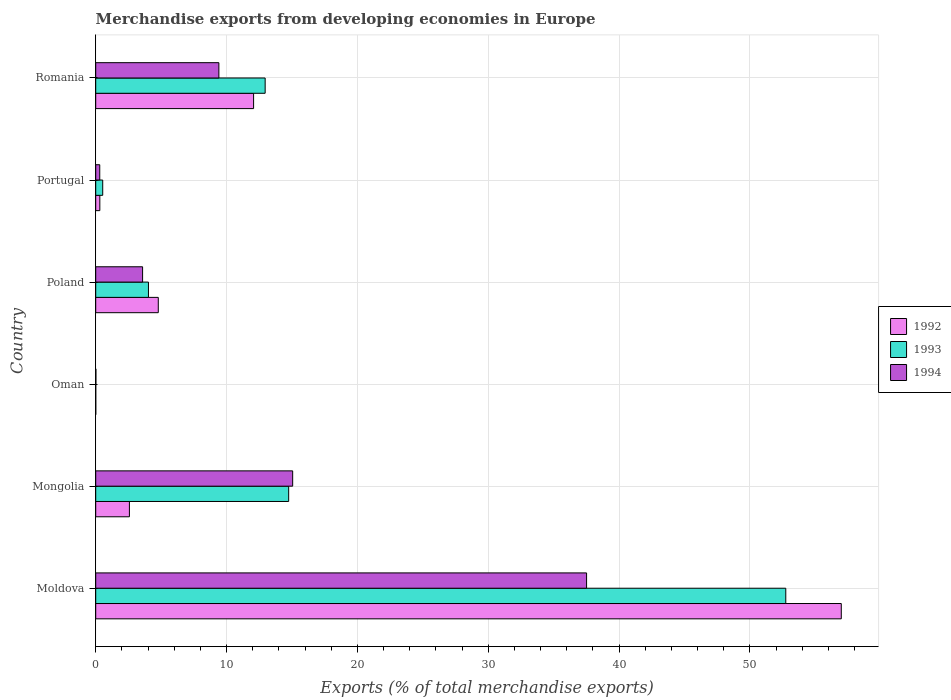Are the number of bars per tick equal to the number of legend labels?
Give a very brief answer. Yes. How many bars are there on the 2nd tick from the top?
Your answer should be compact. 3. What is the label of the 6th group of bars from the top?
Ensure brevity in your answer.  Moldova. What is the percentage of total merchandise exports in 1993 in Portugal?
Your answer should be compact. 0.54. Across all countries, what is the maximum percentage of total merchandise exports in 1993?
Your response must be concise. 52.74. Across all countries, what is the minimum percentage of total merchandise exports in 1993?
Keep it short and to the point. 0. In which country was the percentage of total merchandise exports in 1992 maximum?
Provide a short and direct response. Moldova. In which country was the percentage of total merchandise exports in 1993 minimum?
Offer a very short reply. Oman. What is the total percentage of total merchandise exports in 1993 in the graph?
Give a very brief answer. 85. What is the difference between the percentage of total merchandise exports in 1992 in Moldova and that in Poland?
Keep it short and to the point. 52.2. What is the difference between the percentage of total merchandise exports in 1992 in Moldova and the percentage of total merchandise exports in 1994 in Romania?
Your response must be concise. 47.57. What is the average percentage of total merchandise exports in 1993 per country?
Offer a very short reply. 14.17. What is the difference between the percentage of total merchandise exports in 1992 and percentage of total merchandise exports in 1993 in Mongolia?
Your response must be concise. -12.17. What is the ratio of the percentage of total merchandise exports in 1993 in Oman to that in Poland?
Provide a short and direct response. 0. Is the percentage of total merchandise exports in 1993 in Moldova less than that in Oman?
Provide a succinct answer. No. What is the difference between the highest and the second highest percentage of total merchandise exports in 1992?
Give a very brief answer. 44.91. What is the difference between the highest and the lowest percentage of total merchandise exports in 1993?
Offer a terse response. 52.74. What does the 2nd bar from the bottom in Portugal represents?
Provide a short and direct response. 1993. Is it the case that in every country, the sum of the percentage of total merchandise exports in 1994 and percentage of total merchandise exports in 1992 is greater than the percentage of total merchandise exports in 1993?
Ensure brevity in your answer.  Yes. How many countries are there in the graph?
Keep it short and to the point. 6. What is the difference between two consecutive major ticks on the X-axis?
Keep it short and to the point. 10. Are the values on the major ticks of X-axis written in scientific E-notation?
Ensure brevity in your answer.  No. Where does the legend appear in the graph?
Provide a succinct answer. Center right. How many legend labels are there?
Keep it short and to the point. 3. What is the title of the graph?
Give a very brief answer. Merchandise exports from developing economies in Europe. What is the label or title of the X-axis?
Make the answer very short. Exports (% of total merchandise exports). What is the label or title of the Y-axis?
Offer a very short reply. Country. What is the Exports (% of total merchandise exports) of 1992 in Moldova?
Your answer should be compact. 56.98. What is the Exports (% of total merchandise exports) in 1993 in Moldova?
Keep it short and to the point. 52.74. What is the Exports (% of total merchandise exports) in 1994 in Moldova?
Your answer should be compact. 37.51. What is the Exports (% of total merchandise exports) in 1992 in Mongolia?
Your answer should be very brief. 2.57. What is the Exports (% of total merchandise exports) in 1993 in Mongolia?
Ensure brevity in your answer.  14.75. What is the Exports (% of total merchandise exports) of 1994 in Mongolia?
Keep it short and to the point. 15.05. What is the Exports (% of total merchandise exports) of 1992 in Oman?
Provide a short and direct response. 0. What is the Exports (% of total merchandise exports) of 1993 in Oman?
Give a very brief answer. 0. What is the Exports (% of total merchandise exports) of 1994 in Oman?
Offer a terse response. 0.01. What is the Exports (% of total merchandise exports) in 1992 in Poland?
Keep it short and to the point. 4.78. What is the Exports (% of total merchandise exports) in 1993 in Poland?
Give a very brief answer. 4.03. What is the Exports (% of total merchandise exports) of 1994 in Poland?
Offer a very short reply. 3.58. What is the Exports (% of total merchandise exports) in 1992 in Portugal?
Offer a terse response. 0.32. What is the Exports (% of total merchandise exports) of 1993 in Portugal?
Your response must be concise. 0.54. What is the Exports (% of total merchandise exports) in 1994 in Portugal?
Give a very brief answer. 0.31. What is the Exports (% of total merchandise exports) in 1992 in Romania?
Offer a terse response. 12.07. What is the Exports (% of total merchandise exports) in 1993 in Romania?
Your answer should be very brief. 12.95. What is the Exports (% of total merchandise exports) of 1994 in Romania?
Your response must be concise. 9.41. Across all countries, what is the maximum Exports (% of total merchandise exports) in 1992?
Your response must be concise. 56.98. Across all countries, what is the maximum Exports (% of total merchandise exports) of 1993?
Your response must be concise. 52.74. Across all countries, what is the maximum Exports (% of total merchandise exports) of 1994?
Offer a terse response. 37.51. Across all countries, what is the minimum Exports (% of total merchandise exports) of 1992?
Offer a very short reply. 0. Across all countries, what is the minimum Exports (% of total merchandise exports) of 1993?
Offer a terse response. 0. Across all countries, what is the minimum Exports (% of total merchandise exports) in 1994?
Give a very brief answer. 0.01. What is the total Exports (% of total merchandise exports) of 1992 in the graph?
Offer a terse response. 76.72. What is the total Exports (% of total merchandise exports) of 1993 in the graph?
Provide a short and direct response. 85. What is the total Exports (% of total merchandise exports) in 1994 in the graph?
Offer a very short reply. 65.88. What is the difference between the Exports (% of total merchandise exports) of 1992 in Moldova and that in Mongolia?
Offer a very short reply. 54.4. What is the difference between the Exports (% of total merchandise exports) of 1993 in Moldova and that in Mongolia?
Offer a terse response. 37.99. What is the difference between the Exports (% of total merchandise exports) of 1994 in Moldova and that in Mongolia?
Your response must be concise. 22.46. What is the difference between the Exports (% of total merchandise exports) in 1992 in Moldova and that in Oman?
Your answer should be compact. 56.97. What is the difference between the Exports (% of total merchandise exports) in 1993 in Moldova and that in Oman?
Provide a succinct answer. 52.74. What is the difference between the Exports (% of total merchandise exports) in 1994 in Moldova and that in Oman?
Offer a very short reply. 37.5. What is the difference between the Exports (% of total merchandise exports) of 1992 in Moldova and that in Poland?
Keep it short and to the point. 52.2. What is the difference between the Exports (% of total merchandise exports) of 1993 in Moldova and that in Poland?
Your answer should be compact. 48.71. What is the difference between the Exports (% of total merchandise exports) in 1994 in Moldova and that in Poland?
Make the answer very short. 33.93. What is the difference between the Exports (% of total merchandise exports) in 1992 in Moldova and that in Portugal?
Provide a short and direct response. 56.66. What is the difference between the Exports (% of total merchandise exports) of 1993 in Moldova and that in Portugal?
Provide a succinct answer. 52.2. What is the difference between the Exports (% of total merchandise exports) in 1994 in Moldova and that in Portugal?
Offer a very short reply. 37.2. What is the difference between the Exports (% of total merchandise exports) in 1992 in Moldova and that in Romania?
Make the answer very short. 44.91. What is the difference between the Exports (% of total merchandise exports) of 1993 in Moldova and that in Romania?
Offer a terse response. 39.79. What is the difference between the Exports (% of total merchandise exports) in 1994 in Moldova and that in Romania?
Keep it short and to the point. 28.1. What is the difference between the Exports (% of total merchandise exports) of 1992 in Mongolia and that in Oman?
Provide a succinct answer. 2.57. What is the difference between the Exports (% of total merchandise exports) in 1993 in Mongolia and that in Oman?
Provide a short and direct response. 14.75. What is the difference between the Exports (% of total merchandise exports) of 1994 in Mongolia and that in Oman?
Provide a short and direct response. 15.04. What is the difference between the Exports (% of total merchandise exports) of 1992 in Mongolia and that in Poland?
Give a very brief answer. -2.21. What is the difference between the Exports (% of total merchandise exports) in 1993 in Mongolia and that in Poland?
Your response must be concise. 10.72. What is the difference between the Exports (% of total merchandise exports) in 1994 in Mongolia and that in Poland?
Your answer should be very brief. 11.47. What is the difference between the Exports (% of total merchandise exports) of 1992 in Mongolia and that in Portugal?
Ensure brevity in your answer.  2.26. What is the difference between the Exports (% of total merchandise exports) in 1993 in Mongolia and that in Portugal?
Your answer should be very brief. 14.21. What is the difference between the Exports (% of total merchandise exports) in 1994 in Mongolia and that in Portugal?
Ensure brevity in your answer.  14.74. What is the difference between the Exports (% of total merchandise exports) in 1992 in Mongolia and that in Romania?
Your response must be concise. -9.49. What is the difference between the Exports (% of total merchandise exports) in 1993 in Mongolia and that in Romania?
Ensure brevity in your answer.  1.8. What is the difference between the Exports (% of total merchandise exports) of 1994 in Mongolia and that in Romania?
Make the answer very short. 5.64. What is the difference between the Exports (% of total merchandise exports) of 1992 in Oman and that in Poland?
Keep it short and to the point. -4.78. What is the difference between the Exports (% of total merchandise exports) of 1993 in Oman and that in Poland?
Provide a succinct answer. -4.03. What is the difference between the Exports (% of total merchandise exports) in 1994 in Oman and that in Poland?
Give a very brief answer. -3.57. What is the difference between the Exports (% of total merchandise exports) in 1992 in Oman and that in Portugal?
Your response must be concise. -0.31. What is the difference between the Exports (% of total merchandise exports) of 1993 in Oman and that in Portugal?
Your response must be concise. -0.53. What is the difference between the Exports (% of total merchandise exports) in 1994 in Oman and that in Portugal?
Offer a terse response. -0.29. What is the difference between the Exports (% of total merchandise exports) in 1992 in Oman and that in Romania?
Your answer should be compact. -12.06. What is the difference between the Exports (% of total merchandise exports) in 1993 in Oman and that in Romania?
Your answer should be very brief. -12.95. What is the difference between the Exports (% of total merchandise exports) in 1994 in Oman and that in Romania?
Provide a succinct answer. -9.4. What is the difference between the Exports (% of total merchandise exports) in 1992 in Poland and that in Portugal?
Keep it short and to the point. 4.47. What is the difference between the Exports (% of total merchandise exports) of 1993 in Poland and that in Portugal?
Give a very brief answer. 3.49. What is the difference between the Exports (% of total merchandise exports) of 1994 in Poland and that in Portugal?
Your answer should be compact. 3.27. What is the difference between the Exports (% of total merchandise exports) in 1992 in Poland and that in Romania?
Your answer should be compact. -7.28. What is the difference between the Exports (% of total merchandise exports) in 1993 in Poland and that in Romania?
Keep it short and to the point. -8.92. What is the difference between the Exports (% of total merchandise exports) in 1994 in Poland and that in Romania?
Make the answer very short. -5.83. What is the difference between the Exports (% of total merchandise exports) of 1992 in Portugal and that in Romania?
Ensure brevity in your answer.  -11.75. What is the difference between the Exports (% of total merchandise exports) of 1993 in Portugal and that in Romania?
Keep it short and to the point. -12.41. What is the difference between the Exports (% of total merchandise exports) of 1994 in Portugal and that in Romania?
Ensure brevity in your answer.  -9.1. What is the difference between the Exports (% of total merchandise exports) of 1992 in Moldova and the Exports (% of total merchandise exports) of 1993 in Mongolia?
Offer a terse response. 42.23. What is the difference between the Exports (% of total merchandise exports) in 1992 in Moldova and the Exports (% of total merchandise exports) in 1994 in Mongolia?
Offer a very short reply. 41.93. What is the difference between the Exports (% of total merchandise exports) of 1993 in Moldova and the Exports (% of total merchandise exports) of 1994 in Mongolia?
Provide a succinct answer. 37.69. What is the difference between the Exports (% of total merchandise exports) of 1992 in Moldova and the Exports (% of total merchandise exports) of 1993 in Oman?
Ensure brevity in your answer.  56.98. What is the difference between the Exports (% of total merchandise exports) in 1992 in Moldova and the Exports (% of total merchandise exports) in 1994 in Oman?
Provide a succinct answer. 56.96. What is the difference between the Exports (% of total merchandise exports) in 1993 in Moldova and the Exports (% of total merchandise exports) in 1994 in Oman?
Ensure brevity in your answer.  52.72. What is the difference between the Exports (% of total merchandise exports) of 1992 in Moldova and the Exports (% of total merchandise exports) of 1993 in Poland?
Provide a short and direct response. 52.95. What is the difference between the Exports (% of total merchandise exports) of 1992 in Moldova and the Exports (% of total merchandise exports) of 1994 in Poland?
Give a very brief answer. 53.4. What is the difference between the Exports (% of total merchandise exports) in 1993 in Moldova and the Exports (% of total merchandise exports) in 1994 in Poland?
Your response must be concise. 49.15. What is the difference between the Exports (% of total merchandise exports) of 1992 in Moldova and the Exports (% of total merchandise exports) of 1993 in Portugal?
Make the answer very short. 56.44. What is the difference between the Exports (% of total merchandise exports) in 1992 in Moldova and the Exports (% of total merchandise exports) in 1994 in Portugal?
Your answer should be very brief. 56.67. What is the difference between the Exports (% of total merchandise exports) in 1993 in Moldova and the Exports (% of total merchandise exports) in 1994 in Portugal?
Your response must be concise. 52.43. What is the difference between the Exports (% of total merchandise exports) in 1992 in Moldova and the Exports (% of total merchandise exports) in 1993 in Romania?
Provide a short and direct response. 44.03. What is the difference between the Exports (% of total merchandise exports) in 1992 in Moldova and the Exports (% of total merchandise exports) in 1994 in Romania?
Ensure brevity in your answer.  47.57. What is the difference between the Exports (% of total merchandise exports) of 1993 in Moldova and the Exports (% of total merchandise exports) of 1994 in Romania?
Make the answer very short. 43.32. What is the difference between the Exports (% of total merchandise exports) in 1992 in Mongolia and the Exports (% of total merchandise exports) in 1993 in Oman?
Provide a succinct answer. 2.57. What is the difference between the Exports (% of total merchandise exports) of 1992 in Mongolia and the Exports (% of total merchandise exports) of 1994 in Oman?
Provide a succinct answer. 2.56. What is the difference between the Exports (% of total merchandise exports) of 1993 in Mongolia and the Exports (% of total merchandise exports) of 1994 in Oman?
Give a very brief answer. 14.73. What is the difference between the Exports (% of total merchandise exports) in 1992 in Mongolia and the Exports (% of total merchandise exports) in 1993 in Poland?
Make the answer very short. -1.46. What is the difference between the Exports (% of total merchandise exports) in 1992 in Mongolia and the Exports (% of total merchandise exports) in 1994 in Poland?
Ensure brevity in your answer.  -1.01. What is the difference between the Exports (% of total merchandise exports) of 1993 in Mongolia and the Exports (% of total merchandise exports) of 1994 in Poland?
Provide a short and direct response. 11.16. What is the difference between the Exports (% of total merchandise exports) in 1992 in Mongolia and the Exports (% of total merchandise exports) in 1993 in Portugal?
Give a very brief answer. 2.04. What is the difference between the Exports (% of total merchandise exports) in 1992 in Mongolia and the Exports (% of total merchandise exports) in 1994 in Portugal?
Your response must be concise. 2.27. What is the difference between the Exports (% of total merchandise exports) of 1993 in Mongolia and the Exports (% of total merchandise exports) of 1994 in Portugal?
Provide a short and direct response. 14.44. What is the difference between the Exports (% of total merchandise exports) of 1992 in Mongolia and the Exports (% of total merchandise exports) of 1993 in Romania?
Make the answer very short. -10.37. What is the difference between the Exports (% of total merchandise exports) of 1992 in Mongolia and the Exports (% of total merchandise exports) of 1994 in Romania?
Offer a very short reply. -6.84. What is the difference between the Exports (% of total merchandise exports) in 1993 in Mongolia and the Exports (% of total merchandise exports) in 1994 in Romania?
Offer a terse response. 5.33. What is the difference between the Exports (% of total merchandise exports) in 1992 in Oman and the Exports (% of total merchandise exports) in 1993 in Poland?
Provide a succinct answer. -4.03. What is the difference between the Exports (% of total merchandise exports) in 1992 in Oman and the Exports (% of total merchandise exports) in 1994 in Poland?
Make the answer very short. -3.58. What is the difference between the Exports (% of total merchandise exports) of 1993 in Oman and the Exports (% of total merchandise exports) of 1994 in Poland?
Provide a short and direct response. -3.58. What is the difference between the Exports (% of total merchandise exports) of 1992 in Oman and the Exports (% of total merchandise exports) of 1993 in Portugal?
Offer a very short reply. -0.53. What is the difference between the Exports (% of total merchandise exports) in 1992 in Oman and the Exports (% of total merchandise exports) in 1994 in Portugal?
Make the answer very short. -0.3. What is the difference between the Exports (% of total merchandise exports) in 1993 in Oman and the Exports (% of total merchandise exports) in 1994 in Portugal?
Provide a succinct answer. -0.31. What is the difference between the Exports (% of total merchandise exports) in 1992 in Oman and the Exports (% of total merchandise exports) in 1993 in Romania?
Provide a succinct answer. -12.95. What is the difference between the Exports (% of total merchandise exports) in 1992 in Oman and the Exports (% of total merchandise exports) in 1994 in Romania?
Keep it short and to the point. -9.41. What is the difference between the Exports (% of total merchandise exports) of 1993 in Oman and the Exports (% of total merchandise exports) of 1994 in Romania?
Offer a very short reply. -9.41. What is the difference between the Exports (% of total merchandise exports) in 1992 in Poland and the Exports (% of total merchandise exports) in 1993 in Portugal?
Provide a succinct answer. 4.25. What is the difference between the Exports (% of total merchandise exports) in 1992 in Poland and the Exports (% of total merchandise exports) in 1994 in Portugal?
Offer a terse response. 4.47. What is the difference between the Exports (% of total merchandise exports) of 1993 in Poland and the Exports (% of total merchandise exports) of 1994 in Portugal?
Your answer should be very brief. 3.72. What is the difference between the Exports (% of total merchandise exports) of 1992 in Poland and the Exports (% of total merchandise exports) of 1993 in Romania?
Give a very brief answer. -8.17. What is the difference between the Exports (% of total merchandise exports) of 1992 in Poland and the Exports (% of total merchandise exports) of 1994 in Romania?
Your answer should be compact. -4.63. What is the difference between the Exports (% of total merchandise exports) of 1993 in Poland and the Exports (% of total merchandise exports) of 1994 in Romania?
Provide a succinct answer. -5.38. What is the difference between the Exports (% of total merchandise exports) in 1992 in Portugal and the Exports (% of total merchandise exports) in 1993 in Romania?
Provide a succinct answer. -12.63. What is the difference between the Exports (% of total merchandise exports) in 1992 in Portugal and the Exports (% of total merchandise exports) in 1994 in Romania?
Offer a terse response. -9.1. What is the difference between the Exports (% of total merchandise exports) of 1993 in Portugal and the Exports (% of total merchandise exports) of 1994 in Romania?
Your response must be concise. -8.88. What is the average Exports (% of total merchandise exports) of 1992 per country?
Your answer should be very brief. 12.79. What is the average Exports (% of total merchandise exports) of 1993 per country?
Provide a succinct answer. 14.17. What is the average Exports (% of total merchandise exports) of 1994 per country?
Make the answer very short. 10.98. What is the difference between the Exports (% of total merchandise exports) in 1992 and Exports (% of total merchandise exports) in 1993 in Moldova?
Your answer should be compact. 4.24. What is the difference between the Exports (% of total merchandise exports) in 1992 and Exports (% of total merchandise exports) in 1994 in Moldova?
Offer a very short reply. 19.47. What is the difference between the Exports (% of total merchandise exports) in 1993 and Exports (% of total merchandise exports) in 1994 in Moldova?
Your response must be concise. 15.22. What is the difference between the Exports (% of total merchandise exports) of 1992 and Exports (% of total merchandise exports) of 1993 in Mongolia?
Keep it short and to the point. -12.17. What is the difference between the Exports (% of total merchandise exports) of 1992 and Exports (% of total merchandise exports) of 1994 in Mongolia?
Provide a succinct answer. -12.48. What is the difference between the Exports (% of total merchandise exports) in 1993 and Exports (% of total merchandise exports) in 1994 in Mongolia?
Keep it short and to the point. -0.31. What is the difference between the Exports (% of total merchandise exports) in 1992 and Exports (% of total merchandise exports) in 1993 in Oman?
Your response must be concise. 0. What is the difference between the Exports (% of total merchandise exports) in 1992 and Exports (% of total merchandise exports) in 1994 in Oman?
Make the answer very short. -0.01. What is the difference between the Exports (% of total merchandise exports) of 1993 and Exports (% of total merchandise exports) of 1994 in Oman?
Offer a very short reply. -0.01. What is the difference between the Exports (% of total merchandise exports) in 1992 and Exports (% of total merchandise exports) in 1993 in Poland?
Your answer should be very brief. 0.75. What is the difference between the Exports (% of total merchandise exports) of 1992 and Exports (% of total merchandise exports) of 1994 in Poland?
Provide a short and direct response. 1.2. What is the difference between the Exports (% of total merchandise exports) in 1993 and Exports (% of total merchandise exports) in 1994 in Poland?
Ensure brevity in your answer.  0.45. What is the difference between the Exports (% of total merchandise exports) of 1992 and Exports (% of total merchandise exports) of 1993 in Portugal?
Your answer should be compact. -0.22. What is the difference between the Exports (% of total merchandise exports) of 1992 and Exports (% of total merchandise exports) of 1994 in Portugal?
Your answer should be very brief. 0.01. What is the difference between the Exports (% of total merchandise exports) of 1993 and Exports (% of total merchandise exports) of 1994 in Portugal?
Make the answer very short. 0.23. What is the difference between the Exports (% of total merchandise exports) of 1992 and Exports (% of total merchandise exports) of 1993 in Romania?
Keep it short and to the point. -0.88. What is the difference between the Exports (% of total merchandise exports) in 1992 and Exports (% of total merchandise exports) in 1994 in Romania?
Give a very brief answer. 2.65. What is the difference between the Exports (% of total merchandise exports) in 1993 and Exports (% of total merchandise exports) in 1994 in Romania?
Your response must be concise. 3.54. What is the ratio of the Exports (% of total merchandise exports) in 1992 in Moldova to that in Mongolia?
Your response must be concise. 22.13. What is the ratio of the Exports (% of total merchandise exports) of 1993 in Moldova to that in Mongolia?
Provide a short and direct response. 3.58. What is the ratio of the Exports (% of total merchandise exports) of 1994 in Moldova to that in Mongolia?
Make the answer very short. 2.49. What is the ratio of the Exports (% of total merchandise exports) in 1992 in Moldova to that in Oman?
Give a very brief answer. 1.36e+04. What is the ratio of the Exports (% of total merchandise exports) of 1993 in Moldova to that in Oman?
Your answer should be compact. 3.55e+04. What is the ratio of the Exports (% of total merchandise exports) in 1994 in Moldova to that in Oman?
Your response must be concise. 2631.64. What is the ratio of the Exports (% of total merchandise exports) of 1992 in Moldova to that in Poland?
Your answer should be compact. 11.92. What is the ratio of the Exports (% of total merchandise exports) of 1993 in Moldova to that in Poland?
Offer a very short reply. 13.08. What is the ratio of the Exports (% of total merchandise exports) of 1994 in Moldova to that in Poland?
Ensure brevity in your answer.  10.47. What is the ratio of the Exports (% of total merchandise exports) of 1992 in Moldova to that in Portugal?
Offer a terse response. 180.84. What is the ratio of the Exports (% of total merchandise exports) in 1993 in Moldova to that in Portugal?
Provide a succinct answer. 98.37. What is the ratio of the Exports (% of total merchandise exports) in 1994 in Moldova to that in Portugal?
Keep it short and to the point. 121.39. What is the ratio of the Exports (% of total merchandise exports) in 1992 in Moldova to that in Romania?
Offer a very short reply. 4.72. What is the ratio of the Exports (% of total merchandise exports) in 1993 in Moldova to that in Romania?
Give a very brief answer. 4.07. What is the ratio of the Exports (% of total merchandise exports) of 1994 in Moldova to that in Romania?
Give a very brief answer. 3.99. What is the ratio of the Exports (% of total merchandise exports) of 1992 in Mongolia to that in Oman?
Make the answer very short. 615.69. What is the ratio of the Exports (% of total merchandise exports) of 1993 in Mongolia to that in Oman?
Offer a terse response. 9923.6. What is the ratio of the Exports (% of total merchandise exports) in 1994 in Mongolia to that in Oman?
Your response must be concise. 1055.93. What is the ratio of the Exports (% of total merchandise exports) of 1992 in Mongolia to that in Poland?
Ensure brevity in your answer.  0.54. What is the ratio of the Exports (% of total merchandise exports) of 1993 in Mongolia to that in Poland?
Your answer should be very brief. 3.66. What is the ratio of the Exports (% of total merchandise exports) of 1994 in Mongolia to that in Poland?
Keep it short and to the point. 4.2. What is the ratio of the Exports (% of total merchandise exports) in 1992 in Mongolia to that in Portugal?
Your answer should be very brief. 8.17. What is the ratio of the Exports (% of total merchandise exports) in 1993 in Mongolia to that in Portugal?
Give a very brief answer. 27.51. What is the ratio of the Exports (% of total merchandise exports) of 1994 in Mongolia to that in Portugal?
Offer a very short reply. 48.71. What is the ratio of the Exports (% of total merchandise exports) in 1992 in Mongolia to that in Romania?
Offer a very short reply. 0.21. What is the ratio of the Exports (% of total merchandise exports) of 1993 in Mongolia to that in Romania?
Keep it short and to the point. 1.14. What is the ratio of the Exports (% of total merchandise exports) in 1994 in Mongolia to that in Romania?
Your response must be concise. 1.6. What is the ratio of the Exports (% of total merchandise exports) in 1992 in Oman to that in Poland?
Offer a very short reply. 0. What is the ratio of the Exports (% of total merchandise exports) in 1993 in Oman to that in Poland?
Ensure brevity in your answer.  0. What is the ratio of the Exports (% of total merchandise exports) of 1994 in Oman to that in Poland?
Make the answer very short. 0. What is the ratio of the Exports (% of total merchandise exports) in 1992 in Oman to that in Portugal?
Your answer should be compact. 0.01. What is the ratio of the Exports (% of total merchandise exports) in 1993 in Oman to that in Portugal?
Provide a succinct answer. 0. What is the ratio of the Exports (% of total merchandise exports) of 1994 in Oman to that in Portugal?
Keep it short and to the point. 0.05. What is the ratio of the Exports (% of total merchandise exports) in 1992 in Oman to that in Romania?
Keep it short and to the point. 0. What is the ratio of the Exports (% of total merchandise exports) of 1994 in Oman to that in Romania?
Give a very brief answer. 0. What is the ratio of the Exports (% of total merchandise exports) in 1992 in Poland to that in Portugal?
Your response must be concise. 15.18. What is the ratio of the Exports (% of total merchandise exports) in 1993 in Poland to that in Portugal?
Offer a very short reply. 7.52. What is the ratio of the Exports (% of total merchandise exports) of 1994 in Poland to that in Portugal?
Ensure brevity in your answer.  11.59. What is the ratio of the Exports (% of total merchandise exports) of 1992 in Poland to that in Romania?
Offer a very short reply. 0.4. What is the ratio of the Exports (% of total merchandise exports) in 1993 in Poland to that in Romania?
Keep it short and to the point. 0.31. What is the ratio of the Exports (% of total merchandise exports) of 1994 in Poland to that in Romania?
Your response must be concise. 0.38. What is the ratio of the Exports (% of total merchandise exports) in 1992 in Portugal to that in Romania?
Your answer should be compact. 0.03. What is the ratio of the Exports (% of total merchandise exports) in 1993 in Portugal to that in Romania?
Ensure brevity in your answer.  0.04. What is the ratio of the Exports (% of total merchandise exports) of 1994 in Portugal to that in Romania?
Your answer should be compact. 0.03. What is the difference between the highest and the second highest Exports (% of total merchandise exports) in 1992?
Your response must be concise. 44.91. What is the difference between the highest and the second highest Exports (% of total merchandise exports) of 1993?
Your response must be concise. 37.99. What is the difference between the highest and the second highest Exports (% of total merchandise exports) in 1994?
Your answer should be very brief. 22.46. What is the difference between the highest and the lowest Exports (% of total merchandise exports) of 1992?
Give a very brief answer. 56.97. What is the difference between the highest and the lowest Exports (% of total merchandise exports) of 1993?
Provide a short and direct response. 52.74. What is the difference between the highest and the lowest Exports (% of total merchandise exports) in 1994?
Make the answer very short. 37.5. 